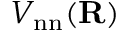<formula> <loc_0><loc_0><loc_500><loc_500>V _ { n n } ( { R } )</formula> 